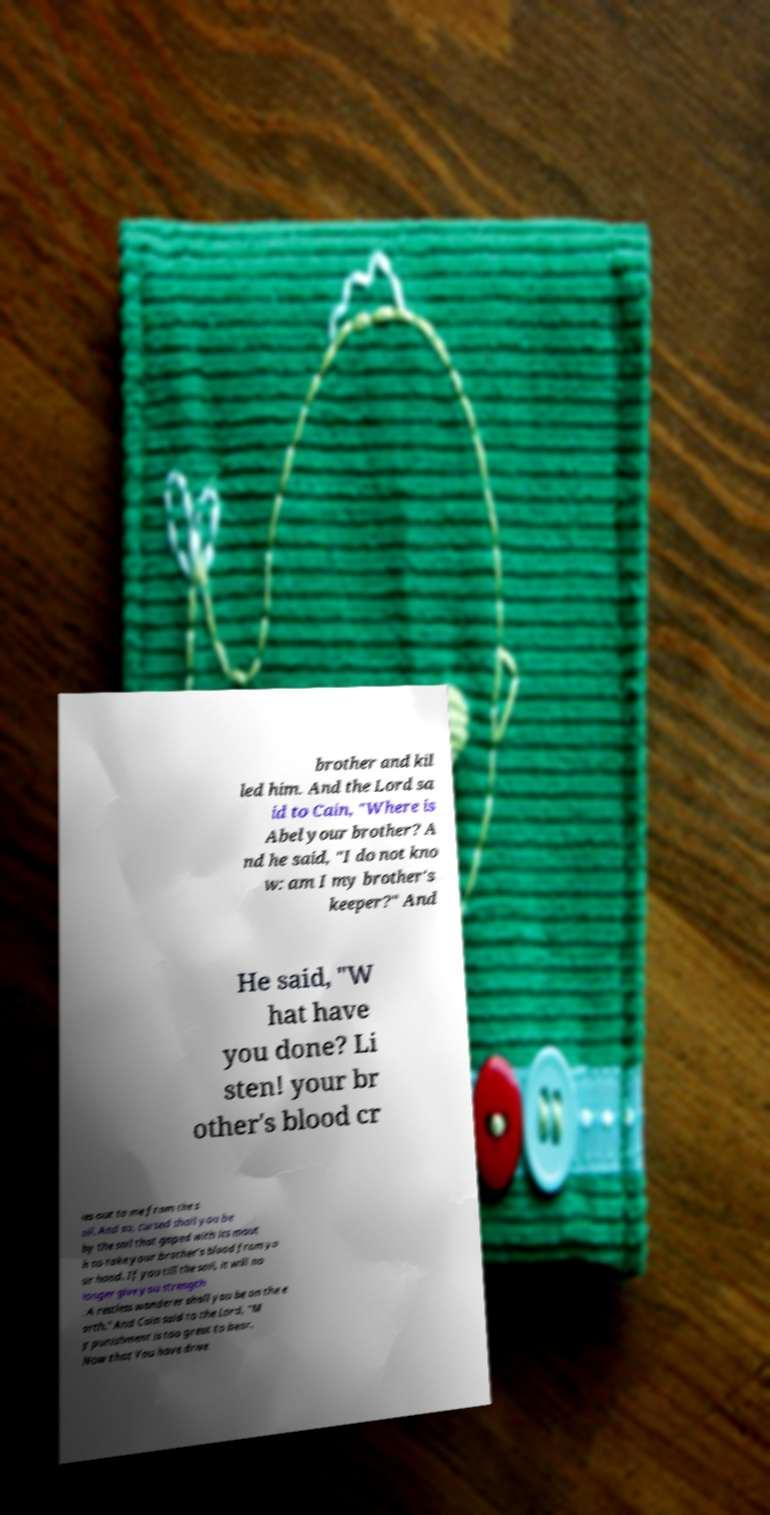What messages or text are displayed in this image? I need them in a readable, typed format. brother and kil led him. And the Lord sa id to Cain, "Where is Abel your brother? A nd he said, "I do not kno w: am I my brother's keeper?" And He said, "W hat have you done? Li sten! your br other's blood cr ies out to me from the s oil. And so, cursed shall you be by the soil that gaped with its mout h to take your brother's blood from yo ur hand. If you till the soil, it will no longer give you strength . A restless wanderer shall you be on the e arth." And Cain said to the Lord, "M y punishment is too great to bear. Now that You have drive 